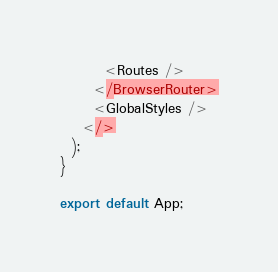<code> <loc_0><loc_0><loc_500><loc_500><_TypeScript_>        <Routes />
      </BrowserRouter>
      <GlobalStyles />
    </>
  );
}

export default App;
</code> 